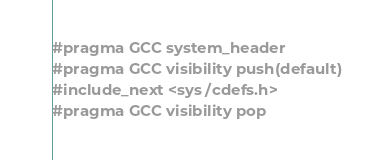<code> <loc_0><loc_0><loc_500><loc_500><_C_>#pragma GCC system_header
#pragma GCC visibility push(default)
#include_next <sys/cdefs.h>
#pragma GCC visibility pop
</code> 